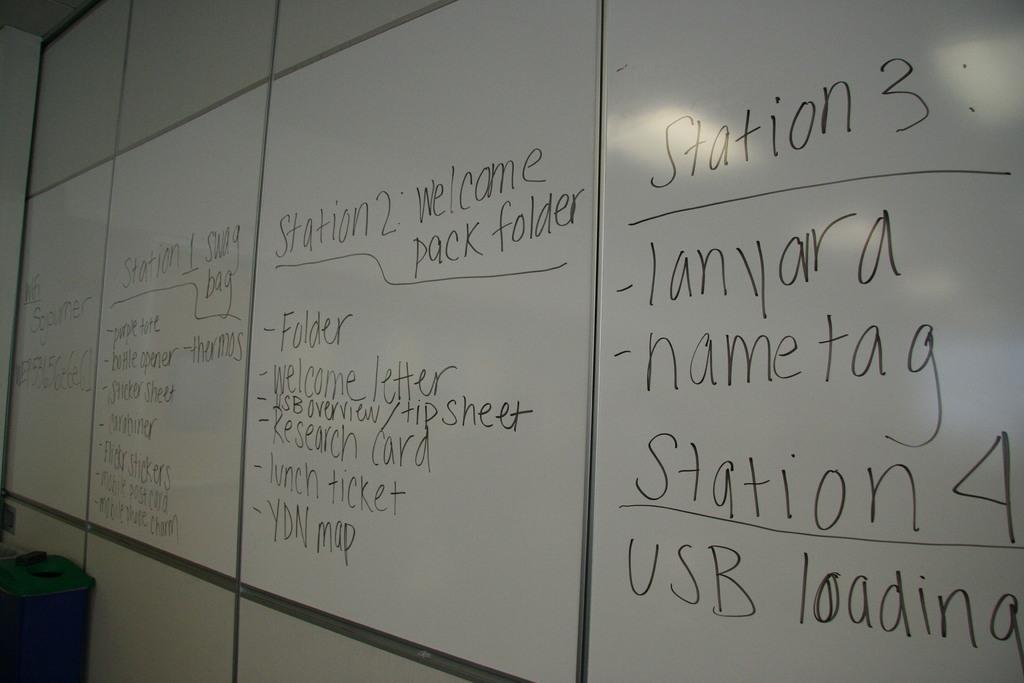<image>
Share a concise interpretation of the image provided. a white board has information about stations and lanyards on it 